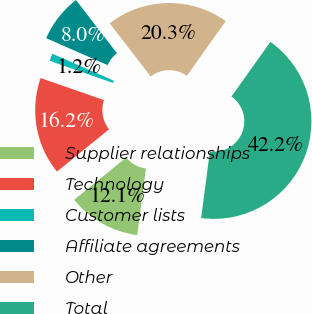<chart> <loc_0><loc_0><loc_500><loc_500><pie_chart><fcel>Supplier relationships<fcel>Technology<fcel>Customer lists<fcel>Affiliate agreements<fcel>Other<fcel>Total<nl><fcel>12.08%<fcel>16.18%<fcel>1.24%<fcel>7.98%<fcel>20.28%<fcel>42.23%<nl></chart> 